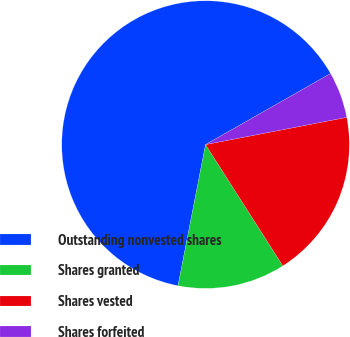Convert chart to OTSL. <chart><loc_0><loc_0><loc_500><loc_500><pie_chart><fcel>Outstanding nonvested shares<fcel>Shares granted<fcel>Shares vested<fcel>Shares forfeited<nl><fcel>63.7%<fcel>12.1%<fcel>19.0%<fcel>5.19%<nl></chart> 